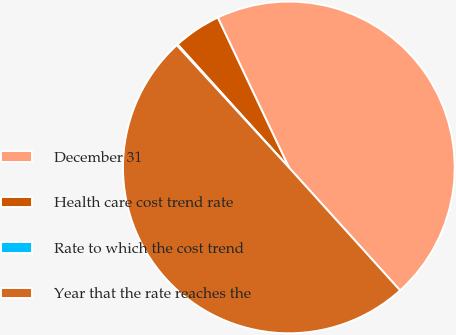Convert chart to OTSL. <chart><loc_0><loc_0><loc_500><loc_500><pie_chart><fcel>December 31<fcel>Health care cost trend rate<fcel>Rate to which the cost trend<fcel>Year that the rate reaches the<nl><fcel>45.35%<fcel>4.65%<fcel>0.11%<fcel>49.89%<nl></chart> 